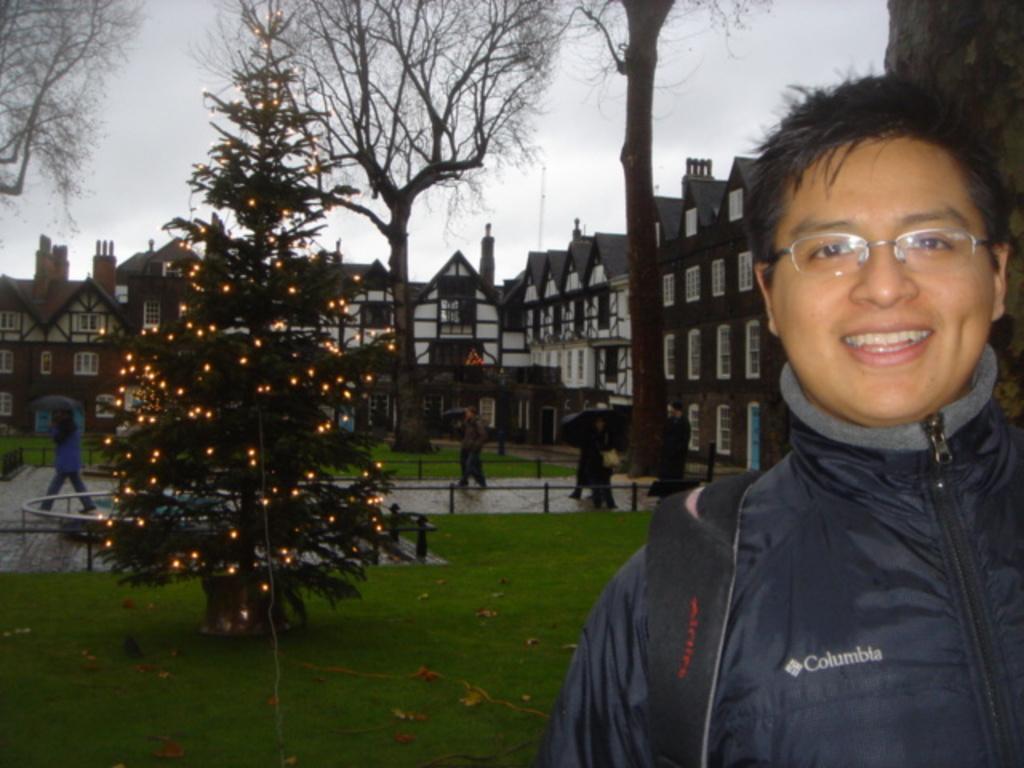In one or two sentences, can you explain what this image depicts? In this picture we can see a group of people were some are walking on the road and holding umbrellas with their hands, fences, grass, Christmas tree with lights on it, buildings with windows, trees and in the background we can see the sky. 